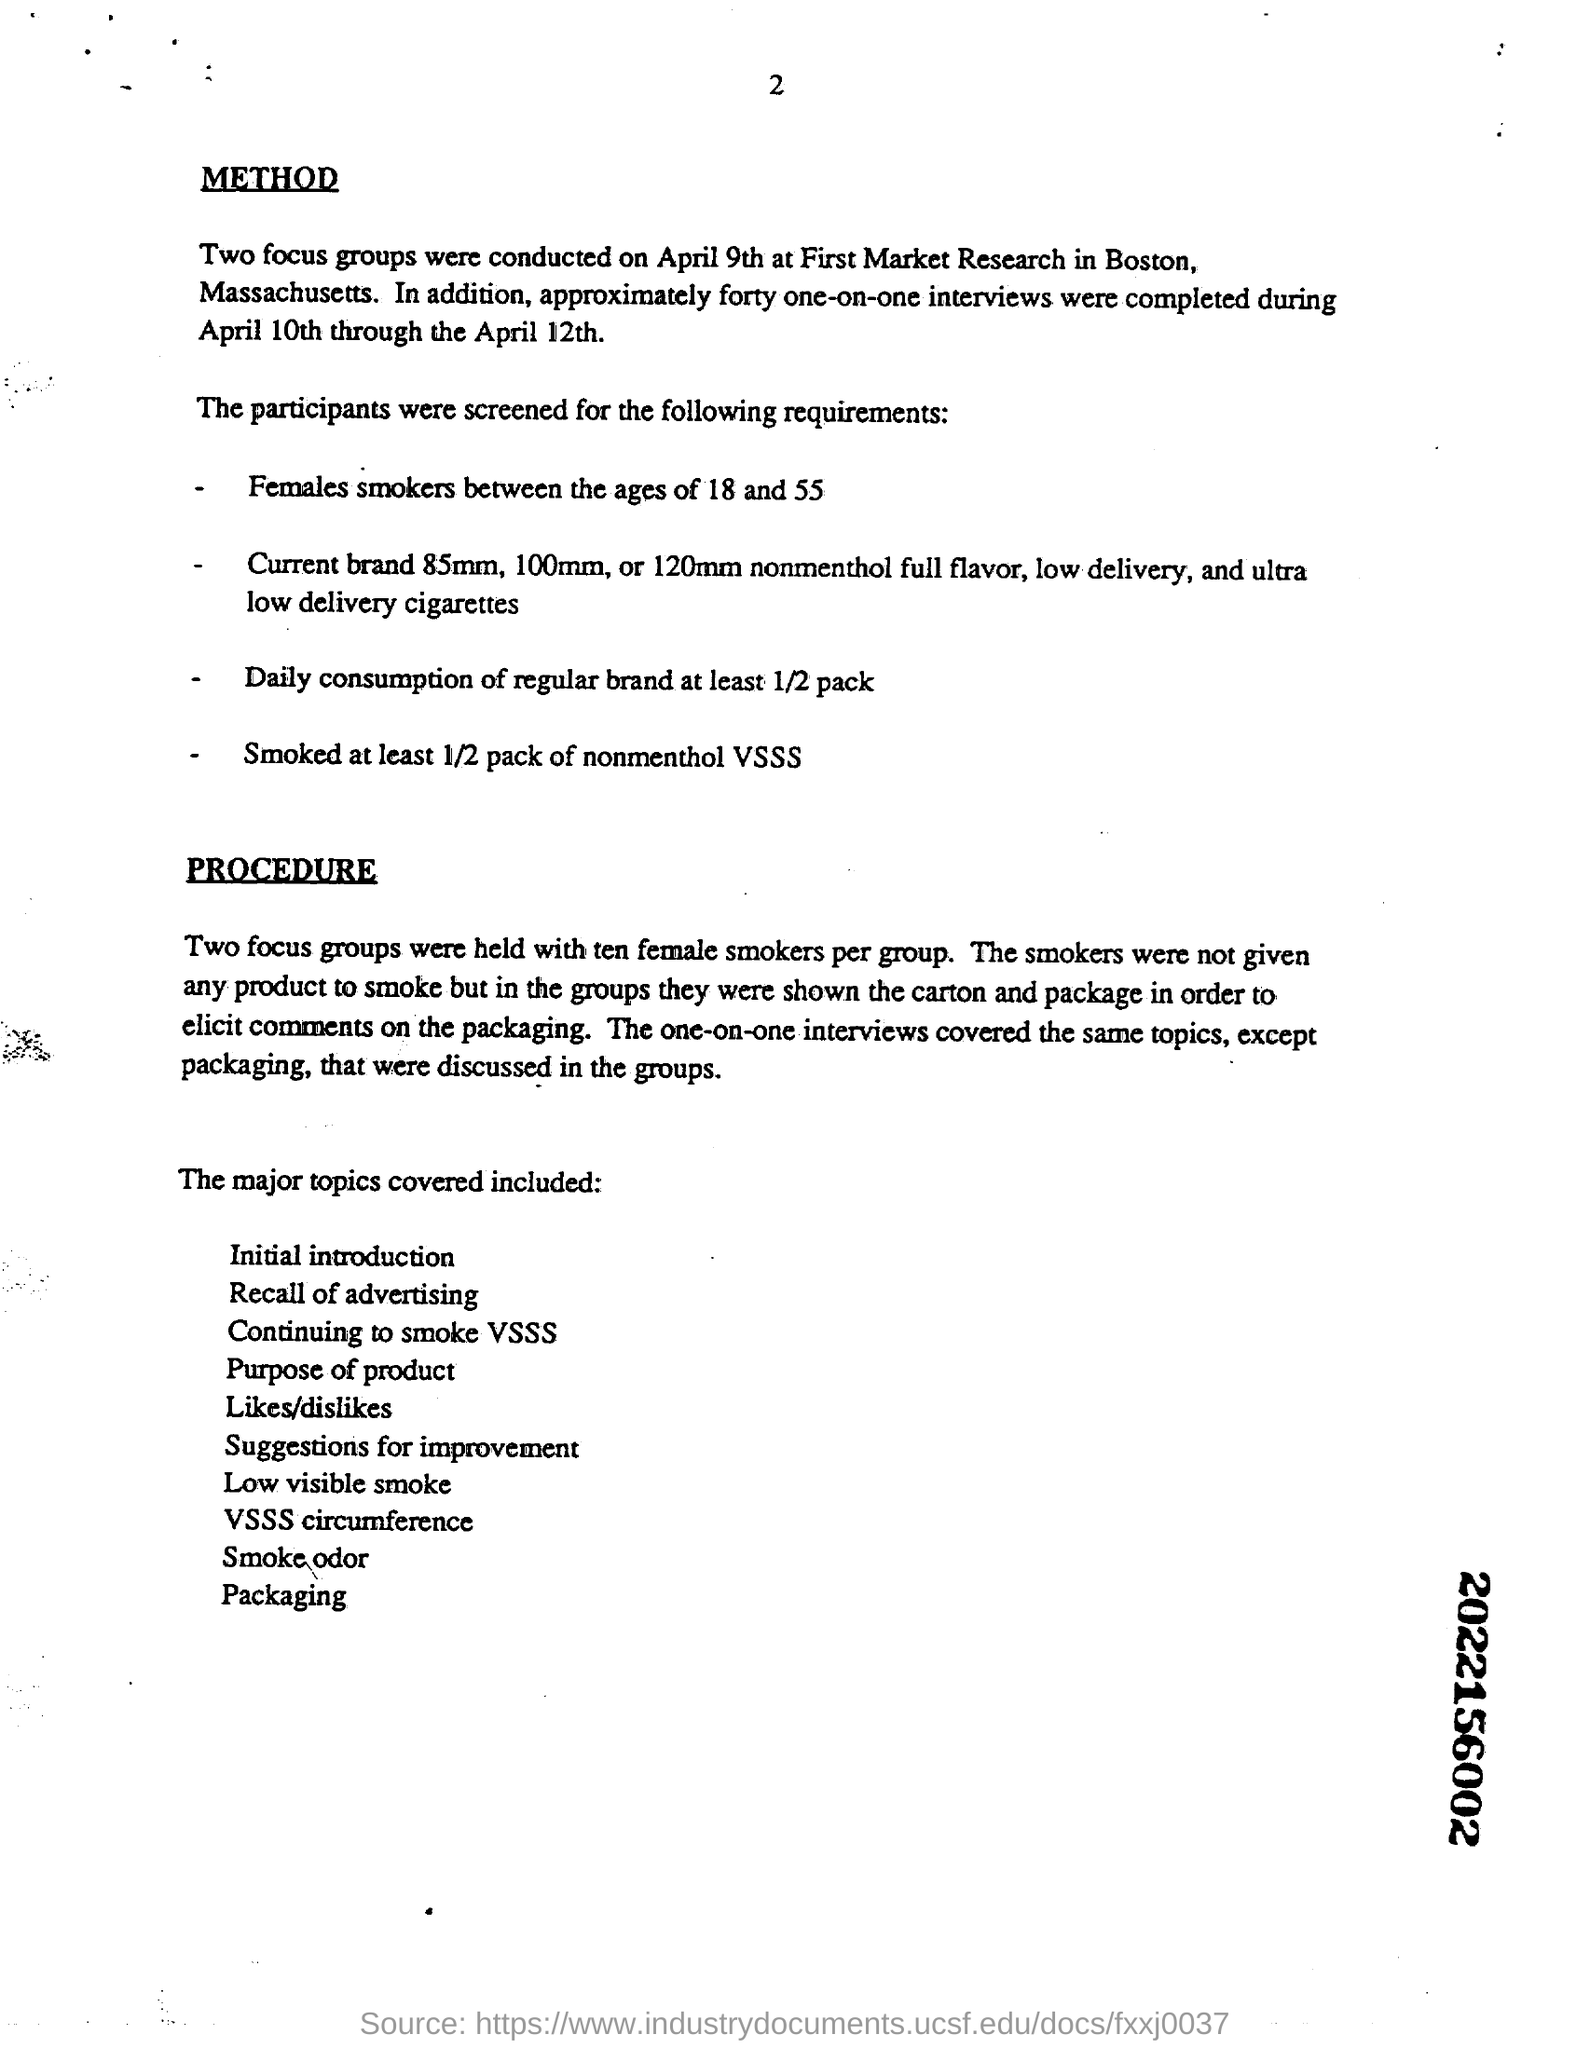Can you provide the screening criteria used for participants in this study? The participants in the study were screened based on several criteria which included being female smokers between the ages of 18 and 55, currently smoking 85mm, 100mm, or 120mm nonmenthol full flavor, low delivery, and ultra low delivery cigarettes, having a daily consumption of regular brand at least half a pack, and smoking at least half a pack of nonmenthol VSSS (Very Special Slim Size) cigarettes. 